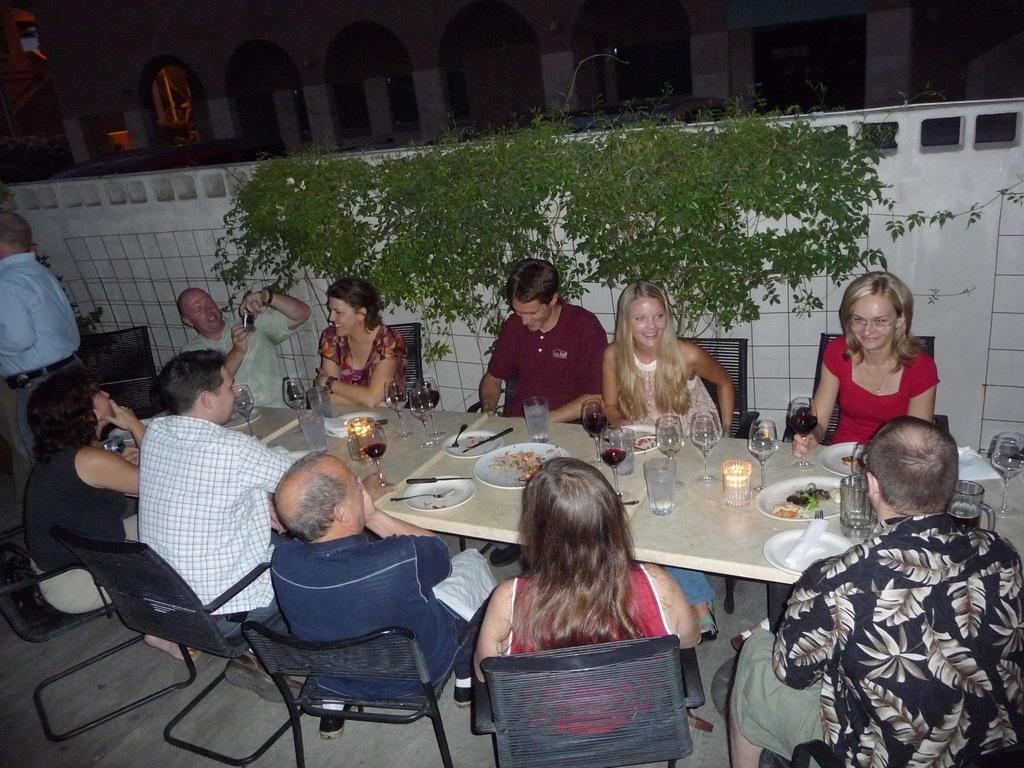Could you give a brief overview of what you see in this image? here in this picture we can see group of people having a party sitting on the chair and having a table in front on them,on the table we can see different different items glasses,plates,spoons e. t. c,here we can also see a creep on the wall. 